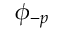Convert formula to latex. <formula><loc_0><loc_0><loc_500><loc_500>\phi _ { - p }</formula> 